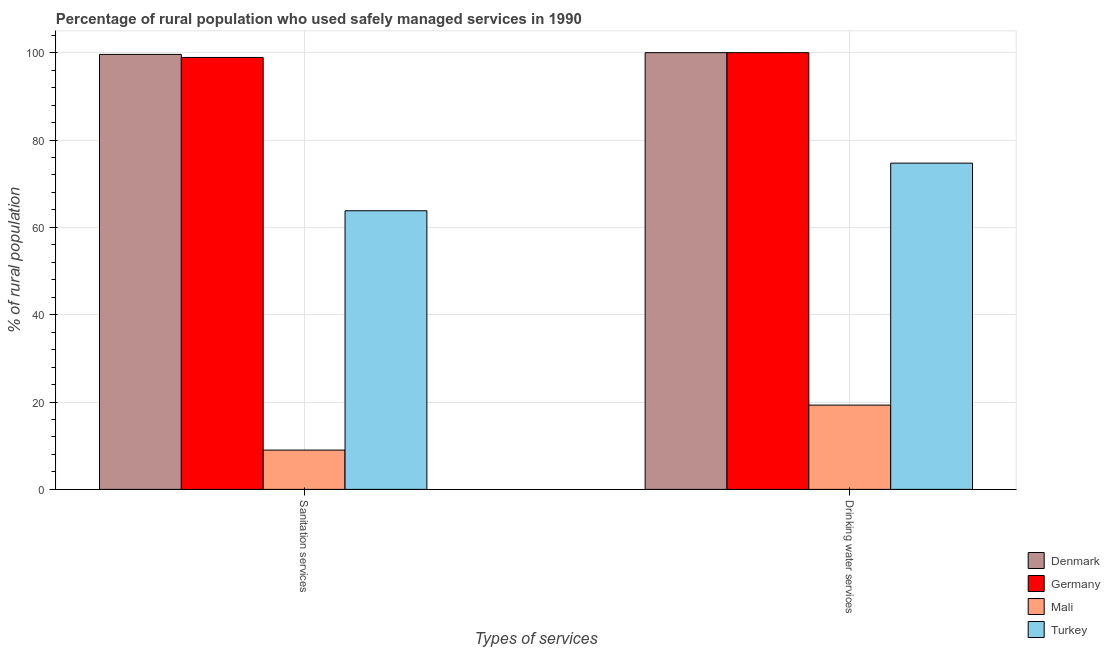How many different coloured bars are there?
Your response must be concise. 4. How many bars are there on the 2nd tick from the left?
Keep it short and to the point. 4. What is the label of the 1st group of bars from the left?
Make the answer very short. Sanitation services. What is the percentage of rural population who used sanitation services in Denmark?
Your answer should be very brief. 99.6. Across all countries, what is the minimum percentage of rural population who used drinking water services?
Your response must be concise. 19.3. In which country was the percentage of rural population who used sanitation services maximum?
Your answer should be compact. Denmark. In which country was the percentage of rural population who used drinking water services minimum?
Your answer should be compact. Mali. What is the total percentage of rural population who used sanitation services in the graph?
Offer a very short reply. 271.3. What is the difference between the percentage of rural population who used drinking water services in Mali and that in Denmark?
Offer a very short reply. -80.7. What is the difference between the percentage of rural population who used drinking water services in Mali and the percentage of rural population who used sanitation services in Denmark?
Provide a succinct answer. -80.3. What is the average percentage of rural population who used sanitation services per country?
Ensure brevity in your answer.  67.83. What is the difference between the percentage of rural population who used sanitation services and percentage of rural population who used drinking water services in Germany?
Provide a short and direct response. -1.1. In how many countries, is the percentage of rural population who used sanitation services greater than 36 %?
Provide a short and direct response. 3. What is the ratio of the percentage of rural population who used drinking water services in Germany to that in Turkey?
Provide a succinct answer. 1.34. What does the 2nd bar from the left in Drinking water services represents?
Give a very brief answer. Germany. Does the graph contain grids?
Provide a succinct answer. Yes. Where does the legend appear in the graph?
Offer a terse response. Bottom right. How many legend labels are there?
Your response must be concise. 4. What is the title of the graph?
Ensure brevity in your answer.  Percentage of rural population who used safely managed services in 1990. What is the label or title of the X-axis?
Your response must be concise. Types of services. What is the label or title of the Y-axis?
Your response must be concise. % of rural population. What is the % of rural population of Denmark in Sanitation services?
Keep it short and to the point. 99.6. What is the % of rural population in Germany in Sanitation services?
Offer a very short reply. 98.9. What is the % of rural population of Mali in Sanitation services?
Provide a short and direct response. 9. What is the % of rural population of Turkey in Sanitation services?
Provide a succinct answer. 63.8. What is the % of rural population of Germany in Drinking water services?
Provide a short and direct response. 100. What is the % of rural population of Mali in Drinking water services?
Offer a very short reply. 19.3. What is the % of rural population in Turkey in Drinking water services?
Your response must be concise. 74.7. Across all Types of services, what is the maximum % of rural population of Mali?
Your answer should be very brief. 19.3. Across all Types of services, what is the maximum % of rural population of Turkey?
Your response must be concise. 74.7. Across all Types of services, what is the minimum % of rural population in Denmark?
Your response must be concise. 99.6. Across all Types of services, what is the minimum % of rural population in Germany?
Ensure brevity in your answer.  98.9. Across all Types of services, what is the minimum % of rural population in Turkey?
Your answer should be very brief. 63.8. What is the total % of rural population in Denmark in the graph?
Ensure brevity in your answer.  199.6. What is the total % of rural population in Germany in the graph?
Provide a short and direct response. 198.9. What is the total % of rural population in Mali in the graph?
Make the answer very short. 28.3. What is the total % of rural population in Turkey in the graph?
Offer a terse response. 138.5. What is the difference between the % of rural population in Denmark in Sanitation services and that in Drinking water services?
Provide a succinct answer. -0.4. What is the difference between the % of rural population of Germany in Sanitation services and that in Drinking water services?
Provide a short and direct response. -1.1. What is the difference between the % of rural population in Mali in Sanitation services and that in Drinking water services?
Provide a short and direct response. -10.3. What is the difference between the % of rural population of Turkey in Sanitation services and that in Drinking water services?
Your answer should be compact. -10.9. What is the difference between the % of rural population of Denmark in Sanitation services and the % of rural population of Germany in Drinking water services?
Keep it short and to the point. -0.4. What is the difference between the % of rural population in Denmark in Sanitation services and the % of rural population in Mali in Drinking water services?
Offer a very short reply. 80.3. What is the difference between the % of rural population of Denmark in Sanitation services and the % of rural population of Turkey in Drinking water services?
Make the answer very short. 24.9. What is the difference between the % of rural population of Germany in Sanitation services and the % of rural population of Mali in Drinking water services?
Make the answer very short. 79.6. What is the difference between the % of rural population in Germany in Sanitation services and the % of rural population in Turkey in Drinking water services?
Make the answer very short. 24.2. What is the difference between the % of rural population in Mali in Sanitation services and the % of rural population in Turkey in Drinking water services?
Ensure brevity in your answer.  -65.7. What is the average % of rural population of Denmark per Types of services?
Your answer should be very brief. 99.8. What is the average % of rural population of Germany per Types of services?
Offer a terse response. 99.45. What is the average % of rural population of Mali per Types of services?
Keep it short and to the point. 14.15. What is the average % of rural population in Turkey per Types of services?
Keep it short and to the point. 69.25. What is the difference between the % of rural population in Denmark and % of rural population in Germany in Sanitation services?
Your response must be concise. 0.7. What is the difference between the % of rural population of Denmark and % of rural population of Mali in Sanitation services?
Ensure brevity in your answer.  90.6. What is the difference between the % of rural population in Denmark and % of rural population in Turkey in Sanitation services?
Offer a very short reply. 35.8. What is the difference between the % of rural population of Germany and % of rural population of Mali in Sanitation services?
Keep it short and to the point. 89.9. What is the difference between the % of rural population of Germany and % of rural population of Turkey in Sanitation services?
Keep it short and to the point. 35.1. What is the difference between the % of rural population in Mali and % of rural population in Turkey in Sanitation services?
Offer a terse response. -54.8. What is the difference between the % of rural population in Denmark and % of rural population in Germany in Drinking water services?
Provide a succinct answer. 0. What is the difference between the % of rural population in Denmark and % of rural population in Mali in Drinking water services?
Provide a short and direct response. 80.7. What is the difference between the % of rural population in Denmark and % of rural population in Turkey in Drinking water services?
Give a very brief answer. 25.3. What is the difference between the % of rural population of Germany and % of rural population of Mali in Drinking water services?
Your answer should be very brief. 80.7. What is the difference between the % of rural population of Germany and % of rural population of Turkey in Drinking water services?
Offer a terse response. 25.3. What is the difference between the % of rural population in Mali and % of rural population in Turkey in Drinking water services?
Provide a succinct answer. -55.4. What is the ratio of the % of rural population of Germany in Sanitation services to that in Drinking water services?
Ensure brevity in your answer.  0.99. What is the ratio of the % of rural population of Mali in Sanitation services to that in Drinking water services?
Give a very brief answer. 0.47. What is the ratio of the % of rural population of Turkey in Sanitation services to that in Drinking water services?
Provide a short and direct response. 0.85. What is the difference between the highest and the second highest % of rural population of Turkey?
Offer a very short reply. 10.9. What is the difference between the highest and the lowest % of rural population in Germany?
Give a very brief answer. 1.1. What is the difference between the highest and the lowest % of rural population of Mali?
Your answer should be compact. 10.3. What is the difference between the highest and the lowest % of rural population of Turkey?
Your answer should be very brief. 10.9. 